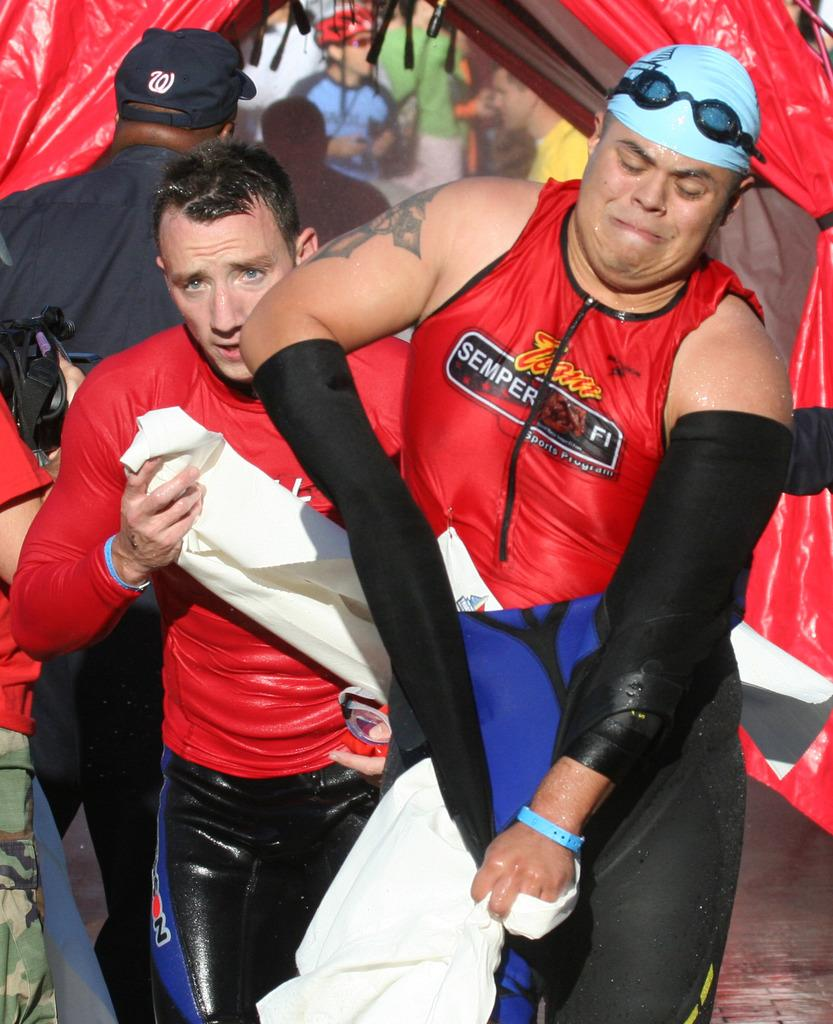<image>
Share a concise interpretation of the image provided. A person peels their sleeve off while wearing a shirt that says semper fi. 